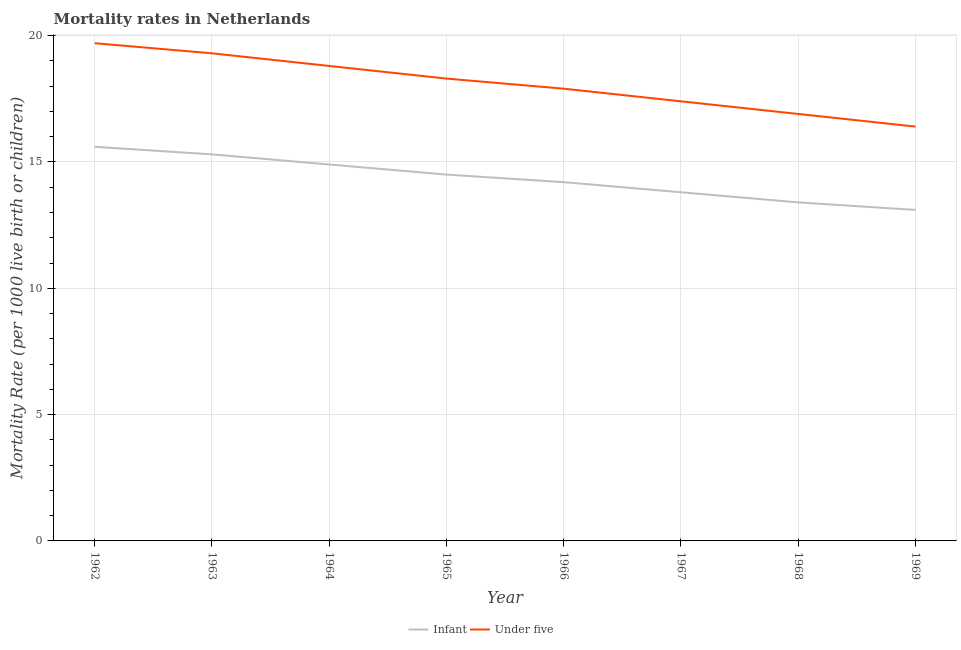How many different coloured lines are there?
Provide a succinct answer. 2. Does the line corresponding to infant mortality rate intersect with the line corresponding to under-5 mortality rate?
Offer a terse response. No. Is the number of lines equal to the number of legend labels?
Your response must be concise. Yes. Across all years, what is the maximum infant mortality rate?
Provide a short and direct response. 15.6. Across all years, what is the minimum under-5 mortality rate?
Give a very brief answer. 16.4. In which year was the under-5 mortality rate maximum?
Ensure brevity in your answer.  1962. In which year was the under-5 mortality rate minimum?
Keep it short and to the point. 1969. What is the total infant mortality rate in the graph?
Your answer should be very brief. 114.8. What is the difference between the under-5 mortality rate in 1962 and that in 1969?
Provide a short and direct response. 3.3. What is the difference between the infant mortality rate in 1969 and the under-5 mortality rate in 1965?
Provide a short and direct response. -5.2. What is the average infant mortality rate per year?
Offer a very short reply. 14.35. In the year 1967, what is the difference between the under-5 mortality rate and infant mortality rate?
Offer a terse response. 3.6. What is the ratio of the under-5 mortality rate in 1962 to that in 1969?
Ensure brevity in your answer.  1.2. What is the difference between the highest and the second highest infant mortality rate?
Your answer should be very brief. 0.3. Is the under-5 mortality rate strictly less than the infant mortality rate over the years?
Keep it short and to the point. No. What is the difference between two consecutive major ticks on the Y-axis?
Offer a terse response. 5. Does the graph contain grids?
Your answer should be very brief. Yes. How many legend labels are there?
Offer a very short reply. 2. How are the legend labels stacked?
Give a very brief answer. Horizontal. What is the title of the graph?
Give a very brief answer. Mortality rates in Netherlands. What is the label or title of the Y-axis?
Provide a succinct answer. Mortality Rate (per 1000 live birth or children). What is the Mortality Rate (per 1000 live birth or children) in Under five in 1963?
Keep it short and to the point. 19.3. What is the Mortality Rate (per 1000 live birth or children) of Infant in 1964?
Keep it short and to the point. 14.9. What is the Mortality Rate (per 1000 live birth or children) in Under five in 1964?
Provide a succinct answer. 18.8. What is the Mortality Rate (per 1000 live birth or children) in Under five in 1965?
Offer a very short reply. 18.3. What is the Mortality Rate (per 1000 live birth or children) in Infant in 1967?
Ensure brevity in your answer.  13.8. What is the Mortality Rate (per 1000 live birth or children) in Infant in 1968?
Your answer should be compact. 13.4. What is the Mortality Rate (per 1000 live birth or children) of Under five in 1968?
Offer a terse response. 16.9. Across all years, what is the maximum Mortality Rate (per 1000 live birth or children) in Infant?
Provide a short and direct response. 15.6. Across all years, what is the maximum Mortality Rate (per 1000 live birth or children) in Under five?
Offer a very short reply. 19.7. What is the total Mortality Rate (per 1000 live birth or children) in Infant in the graph?
Offer a terse response. 114.8. What is the total Mortality Rate (per 1000 live birth or children) of Under five in the graph?
Your answer should be very brief. 144.7. What is the difference between the Mortality Rate (per 1000 live birth or children) of Infant in 1962 and that in 1963?
Provide a succinct answer. 0.3. What is the difference between the Mortality Rate (per 1000 live birth or children) of Under five in 1962 and that in 1963?
Provide a succinct answer. 0.4. What is the difference between the Mortality Rate (per 1000 live birth or children) in Under five in 1962 and that in 1964?
Offer a terse response. 0.9. What is the difference between the Mortality Rate (per 1000 live birth or children) of Infant in 1962 and that in 1966?
Make the answer very short. 1.4. What is the difference between the Mortality Rate (per 1000 live birth or children) in Under five in 1962 and that in 1966?
Ensure brevity in your answer.  1.8. What is the difference between the Mortality Rate (per 1000 live birth or children) in Infant in 1962 and that in 1967?
Give a very brief answer. 1.8. What is the difference between the Mortality Rate (per 1000 live birth or children) in Under five in 1962 and that in 1967?
Offer a terse response. 2.3. What is the difference between the Mortality Rate (per 1000 live birth or children) of Infant in 1962 and that in 1968?
Give a very brief answer. 2.2. What is the difference between the Mortality Rate (per 1000 live birth or children) of Under five in 1962 and that in 1968?
Provide a succinct answer. 2.8. What is the difference between the Mortality Rate (per 1000 live birth or children) of Infant in 1962 and that in 1969?
Give a very brief answer. 2.5. What is the difference between the Mortality Rate (per 1000 live birth or children) in Under five in 1962 and that in 1969?
Your answer should be very brief. 3.3. What is the difference between the Mortality Rate (per 1000 live birth or children) of Under five in 1963 and that in 1966?
Provide a short and direct response. 1.4. What is the difference between the Mortality Rate (per 1000 live birth or children) of Infant in 1963 and that in 1968?
Offer a terse response. 1.9. What is the difference between the Mortality Rate (per 1000 live birth or children) in Under five in 1963 and that in 1968?
Provide a succinct answer. 2.4. What is the difference between the Mortality Rate (per 1000 live birth or children) in Under five in 1963 and that in 1969?
Your answer should be very brief. 2.9. What is the difference between the Mortality Rate (per 1000 live birth or children) of Infant in 1964 and that in 1965?
Ensure brevity in your answer.  0.4. What is the difference between the Mortality Rate (per 1000 live birth or children) in Under five in 1964 and that in 1965?
Offer a terse response. 0.5. What is the difference between the Mortality Rate (per 1000 live birth or children) in Infant in 1964 and that in 1967?
Keep it short and to the point. 1.1. What is the difference between the Mortality Rate (per 1000 live birth or children) of Infant in 1964 and that in 1968?
Offer a very short reply. 1.5. What is the difference between the Mortality Rate (per 1000 live birth or children) in Under five in 1964 and that in 1968?
Your response must be concise. 1.9. What is the difference between the Mortality Rate (per 1000 live birth or children) of Under five in 1965 and that in 1966?
Give a very brief answer. 0.4. What is the difference between the Mortality Rate (per 1000 live birth or children) in Infant in 1965 and that in 1967?
Give a very brief answer. 0.7. What is the difference between the Mortality Rate (per 1000 live birth or children) in Under five in 1965 and that in 1967?
Ensure brevity in your answer.  0.9. What is the difference between the Mortality Rate (per 1000 live birth or children) of Under five in 1965 and that in 1968?
Offer a terse response. 1.4. What is the difference between the Mortality Rate (per 1000 live birth or children) of Infant in 1965 and that in 1969?
Provide a short and direct response. 1.4. What is the difference between the Mortality Rate (per 1000 live birth or children) of Under five in 1966 and that in 1969?
Keep it short and to the point. 1.5. What is the difference between the Mortality Rate (per 1000 live birth or children) of Under five in 1967 and that in 1968?
Keep it short and to the point. 0.5. What is the difference between the Mortality Rate (per 1000 live birth or children) of Under five in 1967 and that in 1969?
Give a very brief answer. 1. What is the difference between the Mortality Rate (per 1000 live birth or children) of Infant in 1968 and that in 1969?
Ensure brevity in your answer.  0.3. What is the difference between the Mortality Rate (per 1000 live birth or children) in Under five in 1968 and that in 1969?
Make the answer very short. 0.5. What is the difference between the Mortality Rate (per 1000 live birth or children) of Infant in 1962 and the Mortality Rate (per 1000 live birth or children) of Under five in 1963?
Ensure brevity in your answer.  -3.7. What is the difference between the Mortality Rate (per 1000 live birth or children) in Infant in 1962 and the Mortality Rate (per 1000 live birth or children) in Under five in 1966?
Your answer should be very brief. -2.3. What is the difference between the Mortality Rate (per 1000 live birth or children) in Infant in 1962 and the Mortality Rate (per 1000 live birth or children) in Under five in 1968?
Give a very brief answer. -1.3. What is the difference between the Mortality Rate (per 1000 live birth or children) of Infant in 1962 and the Mortality Rate (per 1000 live birth or children) of Under five in 1969?
Your answer should be very brief. -0.8. What is the difference between the Mortality Rate (per 1000 live birth or children) in Infant in 1963 and the Mortality Rate (per 1000 live birth or children) in Under five in 1965?
Ensure brevity in your answer.  -3. What is the difference between the Mortality Rate (per 1000 live birth or children) in Infant in 1963 and the Mortality Rate (per 1000 live birth or children) in Under five in 1969?
Ensure brevity in your answer.  -1.1. What is the difference between the Mortality Rate (per 1000 live birth or children) in Infant in 1965 and the Mortality Rate (per 1000 live birth or children) in Under five in 1966?
Your answer should be compact. -3.4. What is the difference between the Mortality Rate (per 1000 live birth or children) of Infant in 1965 and the Mortality Rate (per 1000 live birth or children) of Under five in 1968?
Keep it short and to the point. -2.4. What is the difference between the Mortality Rate (per 1000 live birth or children) in Infant in 1965 and the Mortality Rate (per 1000 live birth or children) in Under five in 1969?
Give a very brief answer. -1.9. What is the difference between the Mortality Rate (per 1000 live birth or children) of Infant in 1966 and the Mortality Rate (per 1000 live birth or children) of Under five in 1968?
Provide a short and direct response. -2.7. What is the difference between the Mortality Rate (per 1000 live birth or children) of Infant in 1966 and the Mortality Rate (per 1000 live birth or children) of Under five in 1969?
Provide a succinct answer. -2.2. What is the difference between the Mortality Rate (per 1000 live birth or children) in Infant in 1968 and the Mortality Rate (per 1000 live birth or children) in Under five in 1969?
Offer a very short reply. -3. What is the average Mortality Rate (per 1000 live birth or children) of Infant per year?
Offer a very short reply. 14.35. What is the average Mortality Rate (per 1000 live birth or children) of Under five per year?
Your answer should be compact. 18.09. In the year 1968, what is the difference between the Mortality Rate (per 1000 live birth or children) in Infant and Mortality Rate (per 1000 live birth or children) in Under five?
Keep it short and to the point. -3.5. In the year 1969, what is the difference between the Mortality Rate (per 1000 live birth or children) of Infant and Mortality Rate (per 1000 live birth or children) of Under five?
Offer a terse response. -3.3. What is the ratio of the Mortality Rate (per 1000 live birth or children) of Infant in 1962 to that in 1963?
Offer a very short reply. 1.02. What is the ratio of the Mortality Rate (per 1000 live birth or children) in Under five in 1962 to that in 1963?
Offer a terse response. 1.02. What is the ratio of the Mortality Rate (per 1000 live birth or children) of Infant in 1962 to that in 1964?
Your answer should be very brief. 1.05. What is the ratio of the Mortality Rate (per 1000 live birth or children) in Under five in 1962 to that in 1964?
Make the answer very short. 1.05. What is the ratio of the Mortality Rate (per 1000 live birth or children) of Infant in 1962 to that in 1965?
Offer a very short reply. 1.08. What is the ratio of the Mortality Rate (per 1000 live birth or children) of Under five in 1962 to that in 1965?
Offer a very short reply. 1.08. What is the ratio of the Mortality Rate (per 1000 live birth or children) of Infant in 1962 to that in 1966?
Offer a very short reply. 1.1. What is the ratio of the Mortality Rate (per 1000 live birth or children) of Under five in 1962 to that in 1966?
Make the answer very short. 1.1. What is the ratio of the Mortality Rate (per 1000 live birth or children) in Infant in 1962 to that in 1967?
Your response must be concise. 1.13. What is the ratio of the Mortality Rate (per 1000 live birth or children) of Under five in 1962 to that in 1967?
Offer a very short reply. 1.13. What is the ratio of the Mortality Rate (per 1000 live birth or children) of Infant in 1962 to that in 1968?
Keep it short and to the point. 1.16. What is the ratio of the Mortality Rate (per 1000 live birth or children) of Under five in 1962 to that in 1968?
Provide a succinct answer. 1.17. What is the ratio of the Mortality Rate (per 1000 live birth or children) in Infant in 1962 to that in 1969?
Provide a succinct answer. 1.19. What is the ratio of the Mortality Rate (per 1000 live birth or children) in Under five in 1962 to that in 1969?
Offer a terse response. 1.2. What is the ratio of the Mortality Rate (per 1000 live birth or children) of Infant in 1963 to that in 1964?
Provide a short and direct response. 1.03. What is the ratio of the Mortality Rate (per 1000 live birth or children) of Under five in 1963 to that in 1964?
Your response must be concise. 1.03. What is the ratio of the Mortality Rate (per 1000 live birth or children) in Infant in 1963 to that in 1965?
Offer a very short reply. 1.06. What is the ratio of the Mortality Rate (per 1000 live birth or children) in Under five in 1963 to that in 1965?
Your answer should be compact. 1.05. What is the ratio of the Mortality Rate (per 1000 live birth or children) of Infant in 1963 to that in 1966?
Ensure brevity in your answer.  1.08. What is the ratio of the Mortality Rate (per 1000 live birth or children) of Under five in 1963 to that in 1966?
Ensure brevity in your answer.  1.08. What is the ratio of the Mortality Rate (per 1000 live birth or children) in Infant in 1963 to that in 1967?
Provide a short and direct response. 1.11. What is the ratio of the Mortality Rate (per 1000 live birth or children) of Under five in 1963 to that in 1967?
Offer a terse response. 1.11. What is the ratio of the Mortality Rate (per 1000 live birth or children) of Infant in 1963 to that in 1968?
Provide a short and direct response. 1.14. What is the ratio of the Mortality Rate (per 1000 live birth or children) of Under five in 1963 to that in 1968?
Give a very brief answer. 1.14. What is the ratio of the Mortality Rate (per 1000 live birth or children) in Infant in 1963 to that in 1969?
Keep it short and to the point. 1.17. What is the ratio of the Mortality Rate (per 1000 live birth or children) of Under five in 1963 to that in 1969?
Offer a very short reply. 1.18. What is the ratio of the Mortality Rate (per 1000 live birth or children) of Infant in 1964 to that in 1965?
Your answer should be compact. 1.03. What is the ratio of the Mortality Rate (per 1000 live birth or children) in Under five in 1964 to that in 1965?
Your answer should be very brief. 1.03. What is the ratio of the Mortality Rate (per 1000 live birth or children) in Infant in 1964 to that in 1966?
Your answer should be very brief. 1.05. What is the ratio of the Mortality Rate (per 1000 live birth or children) of Under five in 1964 to that in 1966?
Offer a very short reply. 1.05. What is the ratio of the Mortality Rate (per 1000 live birth or children) in Infant in 1964 to that in 1967?
Provide a short and direct response. 1.08. What is the ratio of the Mortality Rate (per 1000 live birth or children) of Under five in 1964 to that in 1967?
Provide a succinct answer. 1.08. What is the ratio of the Mortality Rate (per 1000 live birth or children) of Infant in 1964 to that in 1968?
Offer a terse response. 1.11. What is the ratio of the Mortality Rate (per 1000 live birth or children) of Under five in 1964 to that in 1968?
Provide a succinct answer. 1.11. What is the ratio of the Mortality Rate (per 1000 live birth or children) of Infant in 1964 to that in 1969?
Keep it short and to the point. 1.14. What is the ratio of the Mortality Rate (per 1000 live birth or children) in Under five in 1964 to that in 1969?
Provide a succinct answer. 1.15. What is the ratio of the Mortality Rate (per 1000 live birth or children) of Infant in 1965 to that in 1966?
Keep it short and to the point. 1.02. What is the ratio of the Mortality Rate (per 1000 live birth or children) in Under five in 1965 to that in 1966?
Your answer should be compact. 1.02. What is the ratio of the Mortality Rate (per 1000 live birth or children) in Infant in 1965 to that in 1967?
Your answer should be compact. 1.05. What is the ratio of the Mortality Rate (per 1000 live birth or children) in Under five in 1965 to that in 1967?
Keep it short and to the point. 1.05. What is the ratio of the Mortality Rate (per 1000 live birth or children) of Infant in 1965 to that in 1968?
Make the answer very short. 1.08. What is the ratio of the Mortality Rate (per 1000 live birth or children) in Under five in 1965 to that in 1968?
Keep it short and to the point. 1.08. What is the ratio of the Mortality Rate (per 1000 live birth or children) in Infant in 1965 to that in 1969?
Offer a very short reply. 1.11. What is the ratio of the Mortality Rate (per 1000 live birth or children) of Under five in 1965 to that in 1969?
Give a very brief answer. 1.12. What is the ratio of the Mortality Rate (per 1000 live birth or children) of Under five in 1966 to that in 1967?
Keep it short and to the point. 1.03. What is the ratio of the Mortality Rate (per 1000 live birth or children) of Infant in 1966 to that in 1968?
Provide a succinct answer. 1.06. What is the ratio of the Mortality Rate (per 1000 live birth or children) of Under five in 1966 to that in 1968?
Your answer should be compact. 1.06. What is the ratio of the Mortality Rate (per 1000 live birth or children) of Infant in 1966 to that in 1969?
Provide a succinct answer. 1.08. What is the ratio of the Mortality Rate (per 1000 live birth or children) in Under five in 1966 to that in 1969?
Provide a succinct answer. 1.09. What is the ratio of the Mortality Rate (per 1000 live birth or children) of Infant in 1967 to that in 1968?
Your response must be concise. 1.03. What is the ratio of the Mortality Rate (per 1000 live birth or children) of Under five in 1967 to that in 1968?
Your answer should be very brief. 1.03. What is the ratio of the Mortality Rate (per 1000 live birth or children) of Infant in 1967 to that in 1969?
Make the answer very short. 1.05. What is the ratio of the Mortality Rate (per 1000 live birth or children) of Under five in 1967 to that in 1969?
Your answer should be compact. 1.06. What is the ratio of the Mortality Rate (per 1000 live birth or children) in Infant in 1968 to that in 1969?
Your response must be concise. 1.02. What is the ratio of the Mortality Rate (per 1000 live birth or children) in Under five in 1968 to that in 1969?
Provide a succinct answer. 1.03. What is the difference between the highest and the second highest Mortality Rate (per 1000 live birth or children) in Infant?
Offer a terse response. 0.3. What is the difference between the highest and the lowest Mortality Rate (per 1000 live birth or children) of Infant?
Your answer should be very brief. 2.5. 